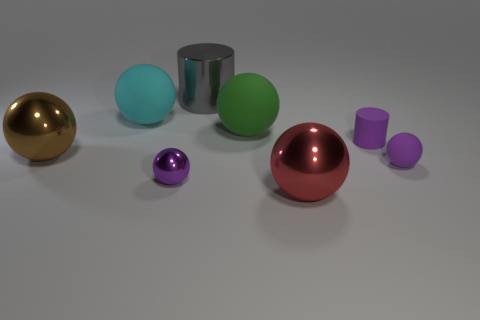Subtract all big brown balls. How many balls are left? 5 Subtract all gray cylinders. How many cylinders are left? 1 Add 2 big red metallic objects. How many objects exist? 10 Subtract 2 spheres. How many spheres are left? 4 Add 3 matte objects. How many matte objects are left? 7 Add 8 purple rubber balls. How many purple rubber balls exist? 9 Subtract 0 brown cylinders. How many objects are left? 8 Subtract all spheres. How many objects are left? 2 Subtract all brown balls. Subtract all gray cubes. How many balls are left? 5 Subtract all blue blocks. How many red balls are left? 1 